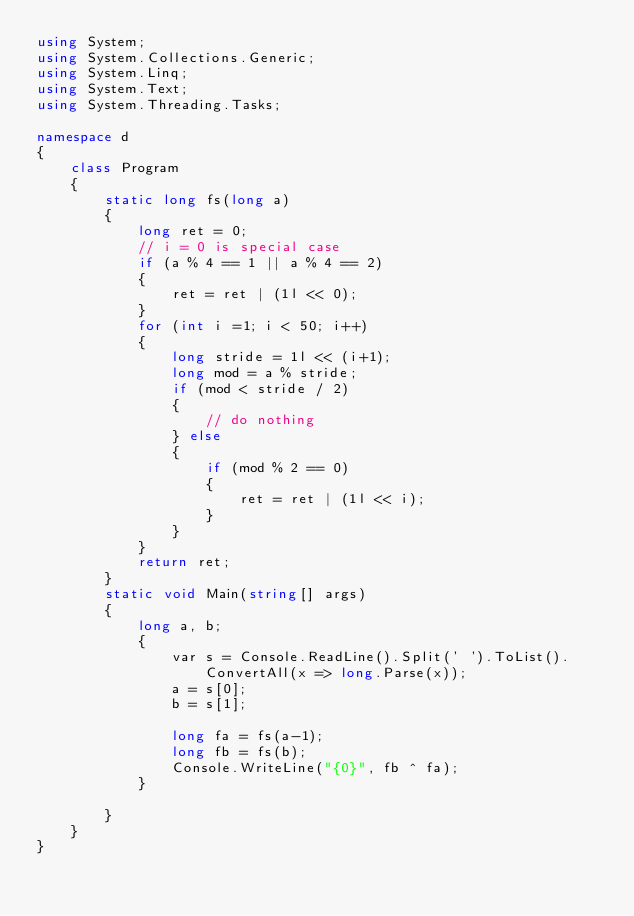<code> <loc_0><loc_0><loc_500><loc_500><_C#_>using System;
using System.Collections.Generic;
using System.Linq;
using System.Text;
using System.Threading.Tasks;

namespace d
{
    class Program
    {
        static long fs(long a)
        {
            long ret = 0;
            // i = 0 is special case
            if (a % 4 == 1 || a % 4 == 2)
            {
                ret = ret | (1l << 0);
            }
            for (int i =1; i < 50; i++)
            {
                long stride = 1l << (i+1);
                long mod = a % stride;
                if (mod < stride / 2)
                {
                    // do nothing    
                } else
                {
                    if (mod % 2 == 0)
                    {
                        ret = ret | (1l << i);
                    }
                }
            }
            return ret;
        }
        static void Main(string[] args)
        {
            long a, b;
            {
                var s = Console.ReadLine().Split(' ').ToList().ConvertAll(x => long.Parse(x));
                a = s[0];
                b = s[1];

                long fa = fs(a-1);
                long fb = fs(b);
                Console.WriteLine("{0}", fb ^ fa);
            }

        }
    }
}
</code> 